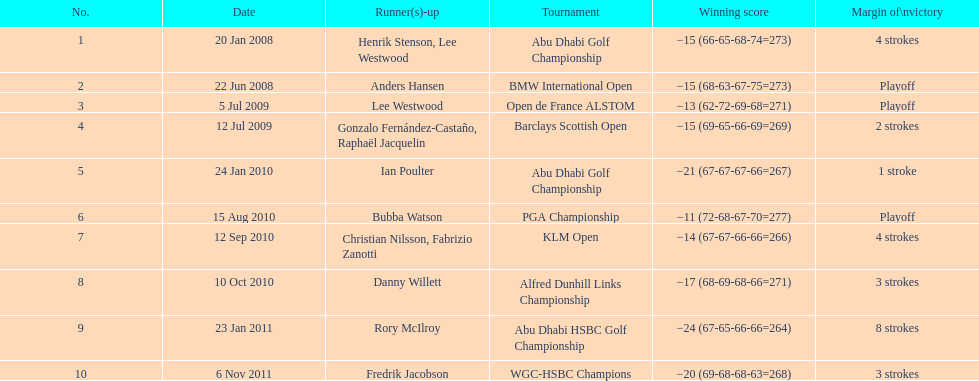Which tournaments did martin kaymer participate in? Abu Dhabi Golf Championship, BMW International Open, Open de France ALSTOM, Barclays Scottish Open, Abu Dhabi Golf Championship, PGA Championship, KLM Open, Alfred Dunhill Links Championship, Abu Dhabi HSBC Golf Championship, WGC-HSBC Champions. How many of these tournaments were won through a playoff? BMW International Open, Open de France ALSTOM, PGA Championship. Which of those tournaments took place in 2010? PGA Championship. Who had to top score next to martin kaymer for that tournament? Bubba Watson. 